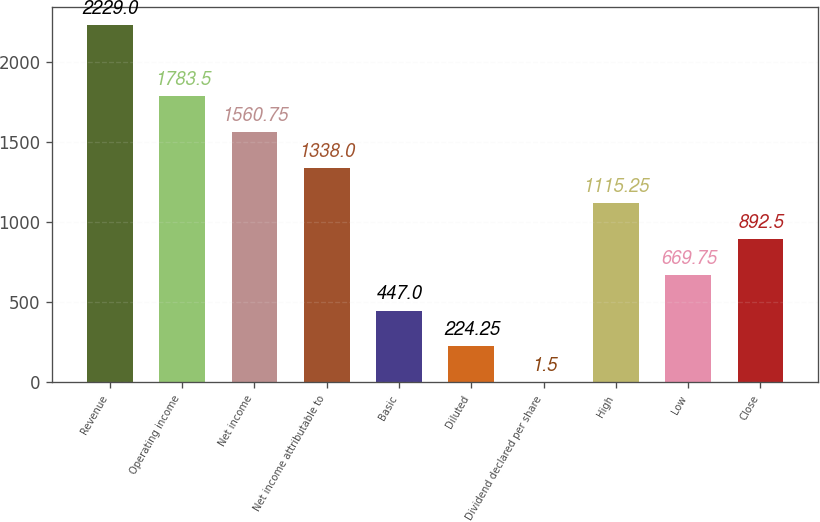Convert chart. <chart><loc_0><loc_0><loc_500><loc_500><bar_chart><fcel>Revenue<fcel>Operating income<fcel>Net income<fcel>Net income attributable to<fcel>Basic<fcel>Diluted<fcel>Dividend declared per share<fcel>High<fcel>Low<fcel>Close<nl><fcel>2229<fcel>1783.5<fcel>1560.75<fcel>1338<fcel>447<fcel>224.25<fcel>1.5<fcel>1115.25<fcel>669.75<fcel>892.5<nl></chart> 